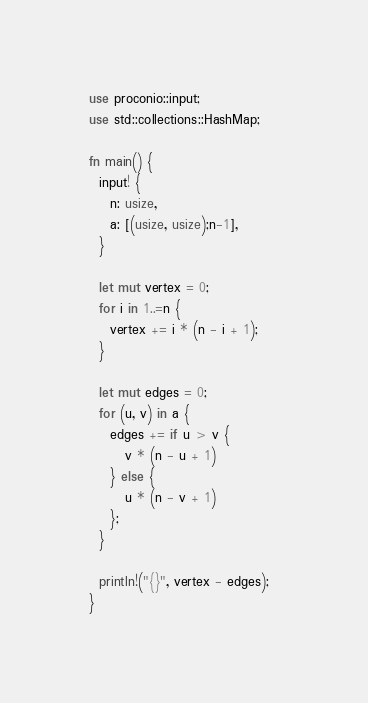<code> <loc_0><loc_0><loc_500><loc_500><_Rust_>use proconio::input;
use std::collections::HashMap;
 
fn main() {
  input! {
    n: usize,
    a: [(usize, usize);n-1],
  }
  
  let mut vertex = 0;
  for i in 1..=n {
    vertex += i * (n - i + 1);
  }
  
  let mut edges = 0;
  for (u, v) in a {
    edges += if u > v {
       v * (n - u + 1) 
    } else {
       u * (n - v + 1)
    };
  }
  
  println!("{}", vertex - edges);  
}</code> 